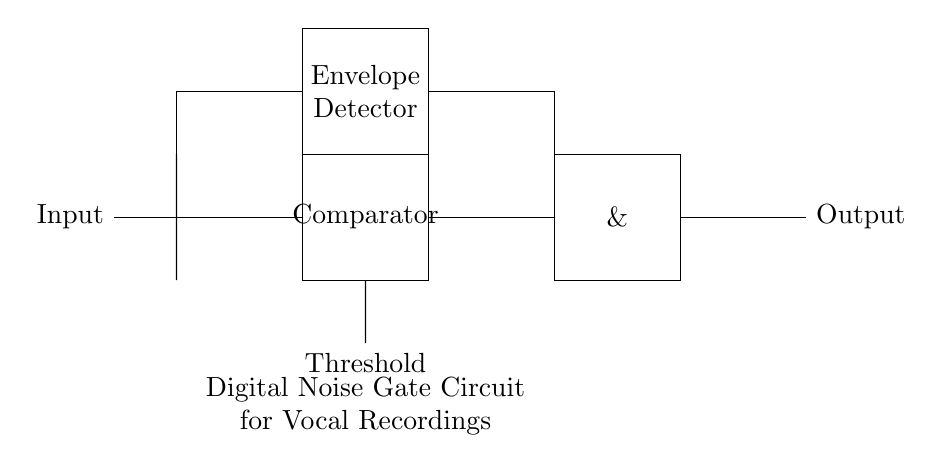What is the function of the comparator in this circuit? The comparator's role is to compare the input signal against a set threshold level. When the input signal exceeds the threshold, it will trigger a change in the output state, allowing the signal to pass through the gate.
Answer: Comparator What components are used to build the noise gate? The components visible in the circuit are a comparator, an AND gate, and an envelope detector. These elements work together to filter out background noise from vocal recordings.
Answer: Comparator, AND gate, envelope detector What does the threshold represent in this circuit? The threshold is the predefined level that the input signal must exceed for the noise gate to activate. It establishes the minimum amplitude required for the gate to allow signal passage.
Answer: Minimum amplitude Which part of the circuit is responsible for detecting the amplitude of the input signal? The envelope detector monitors the amplitude of the input signal. It generates a smoothed output that reflects the signal's peak levels over time, which is crucial for determining whether the threshold is surpassed.
Answer: Envelope detector How many gates are involved in this digital noise gate circuit? There are two gates involved: one comparator and one AND gate. The comparator evaluates the input against the threshold, and the AND gate combines signals to produce the final output.
Answer: Two What is the output of the circuit when the input signal is below the threshold? When the input signal is below the threshold, the output of the noise gate will be low or silent, effectively muting any background noise and preventing it from being recorded.
Answer: Low What is the purpose of using an AND gate in this circuit? The AND gate combines the outputs from the comparator and the envelope detector. It ensures that the output only signals when both conditions—input exceeding the threshold and adequate signal amplitude—are met.
Answer: To combine signals 